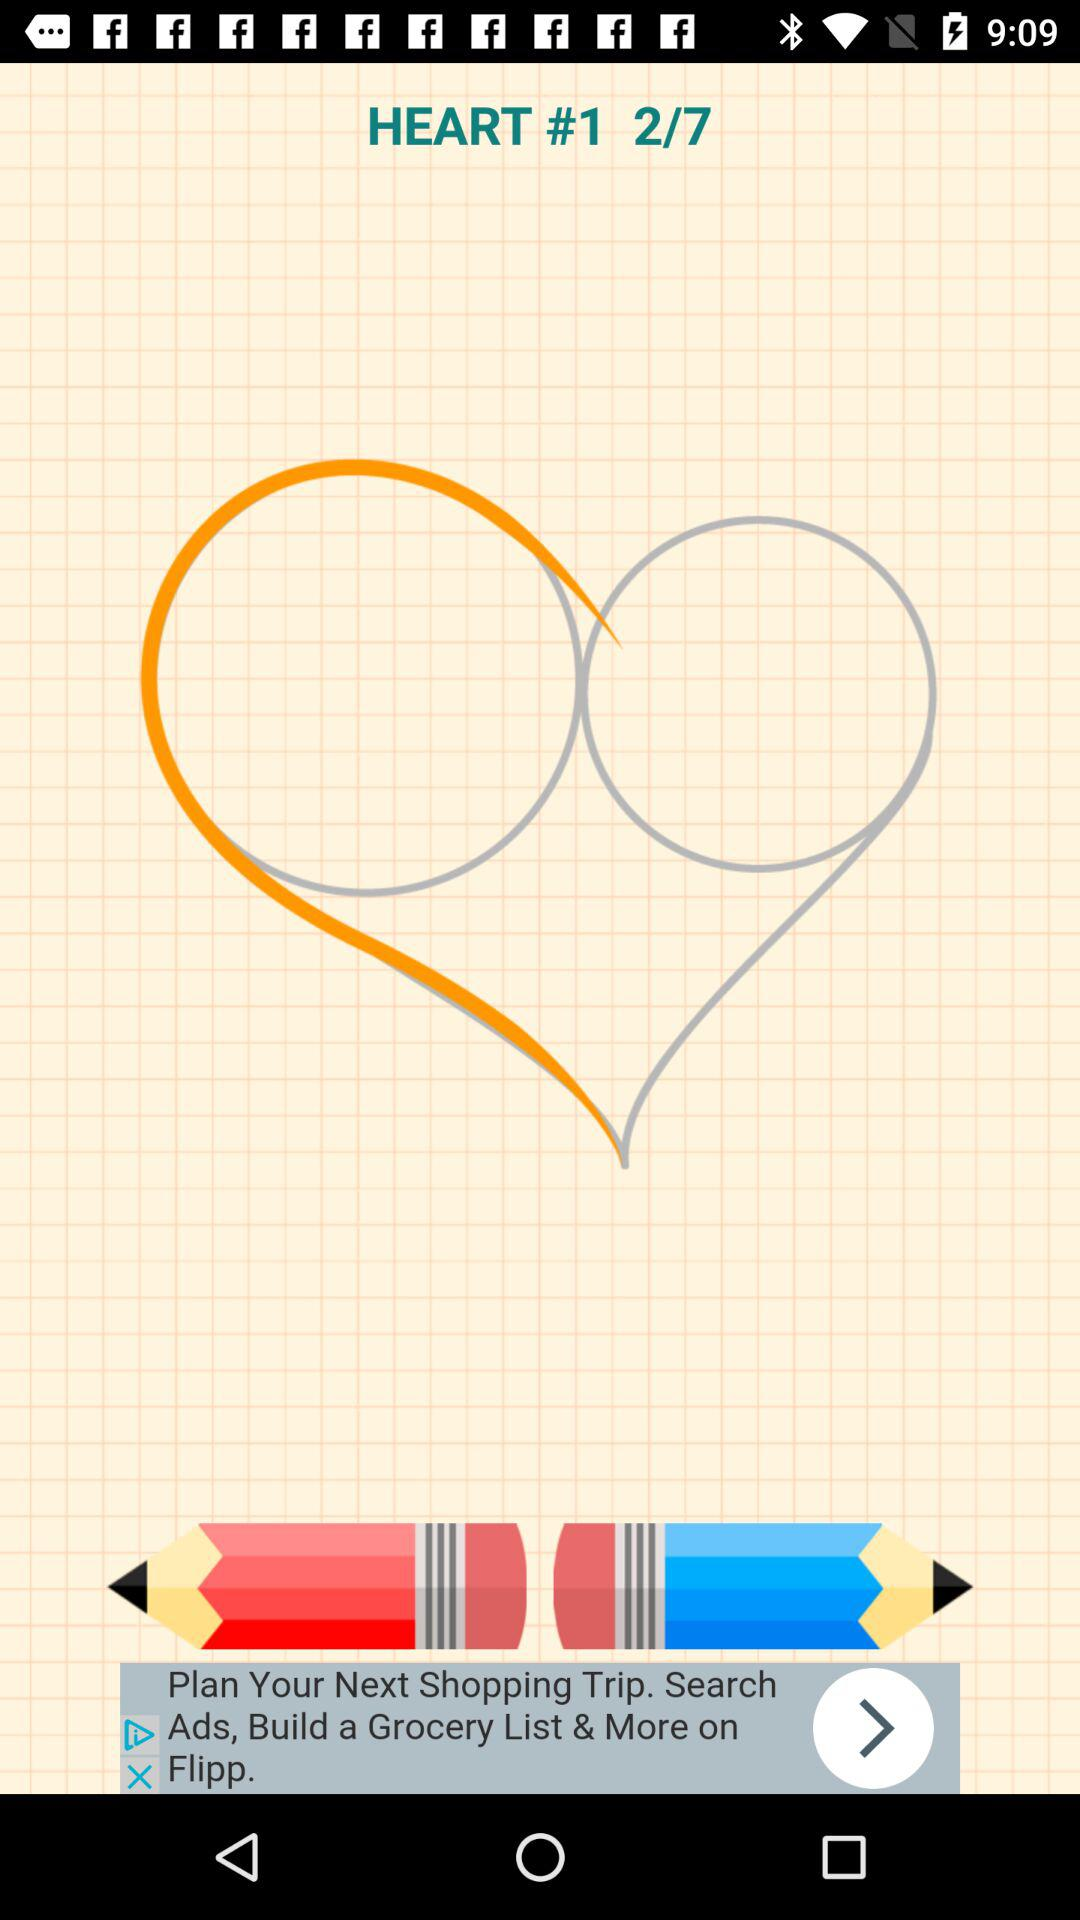What is the total number of images? The total number of images is 7. 